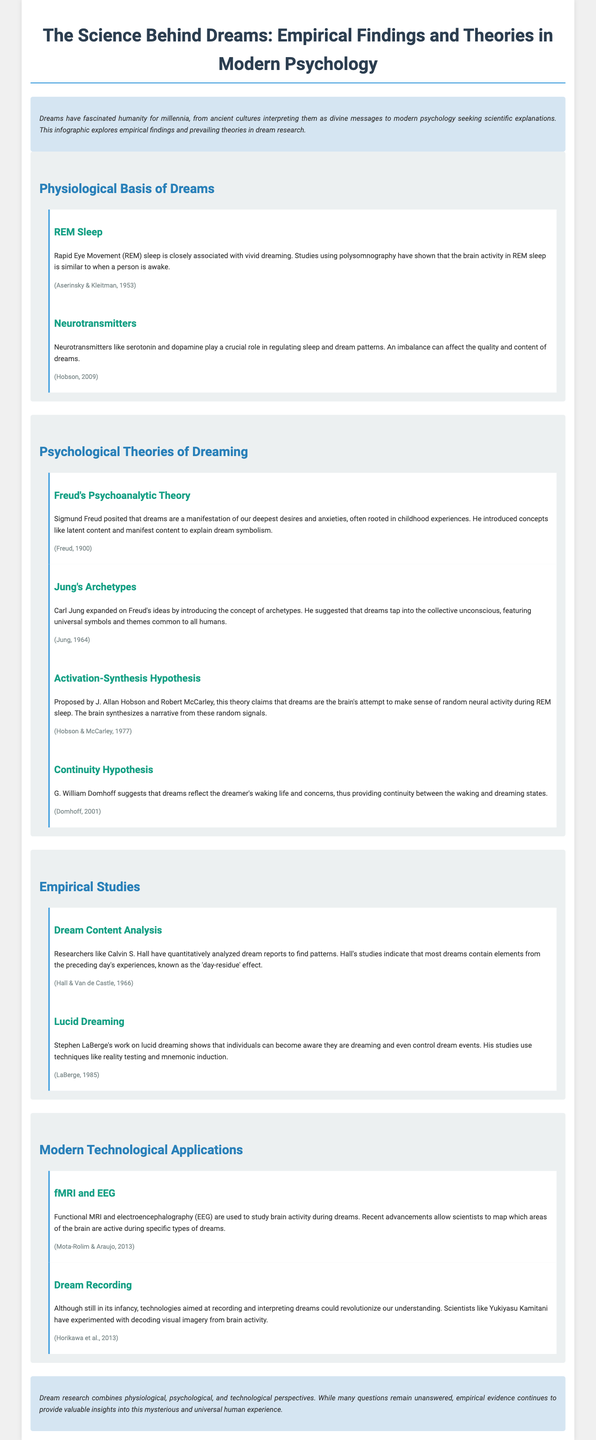what is the primary focus of the infographic? The infographic explores empirical findings and prevailing theories in dream research.
Answer: empirical findings and prevailing theories in dream research who proposed the Activation-Synthesis Hypothesis? The theory was proposed by J. Allan Hobson and Robert McCarley.
Answer: J. Allan Hobson and Robert McCarley which neurotransmitter is mentioned as playing a crucial role in regulating sleep and dream patterns? The document mentions serotonin and dopamine as important neurotransmitters.
Answer: serotonin and dopamine what is the 'day-residue' effect? The 'day-residue' effect refers to the phenomenon where most dreams contain elements from the preceding day's experiences.
Answer: elements from the preceding day's experiences what technological methods are used to study brain activity during dreams? Functional MRI and electroencephalography (EEG) are used to study brain activity.
Answer: Functional MRI and electroencephalography (EEG) who conducted quantitative analysis on dream reports? Calvin S. Hall conducted the quantitative analysis on dream reports.
Answer: Calvin S. Hall what year was Freud's psychoanalytic theory published? Freud's psychoanalytic theory was published in 1900.
Answer: 1900 how do dreams provide continuity between waking and dreaming states according to G. William Domhoff? Domhoff suggests that dreams reflect the dreamer's waking life and concerns.
Answer: reflect the dreamer's waking life and concerns what experimental technique did Stephen LaBerge use in his studies on lucid dreaming? LaBerge used techniques like reality testing and mnemonic induction.
Answer: reality testing and mnemonic induction 